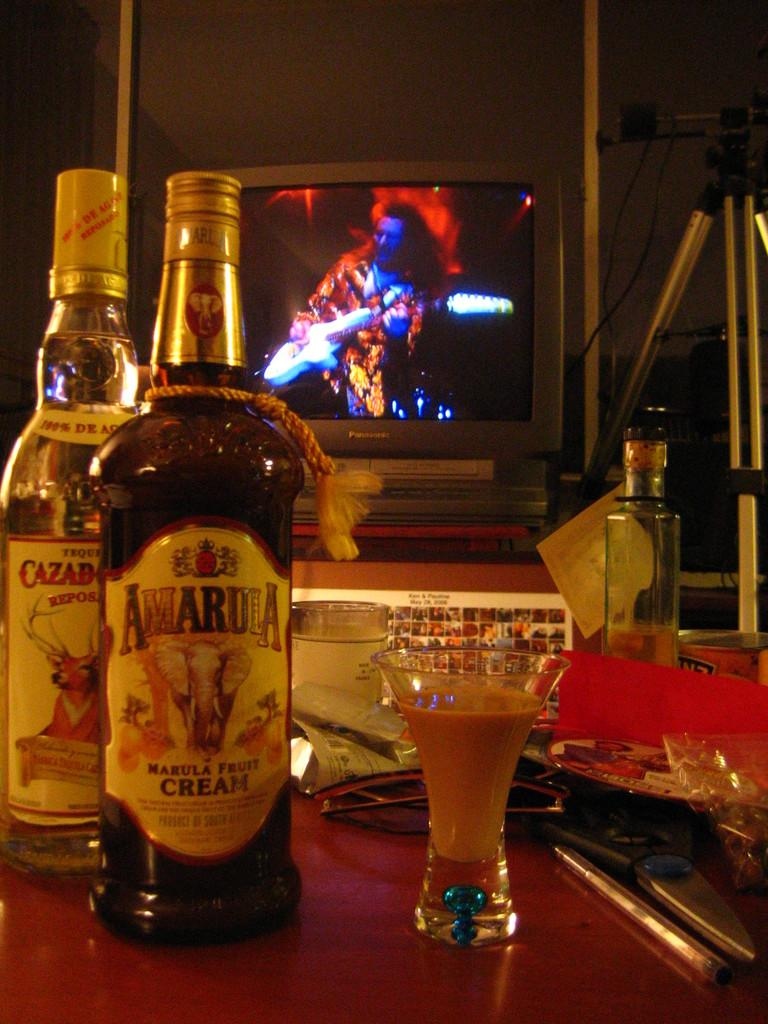<image>
Relay a brief, clear account of the picture shown. A bottle of Amarduia cream is on a table with a TV on in the background. 